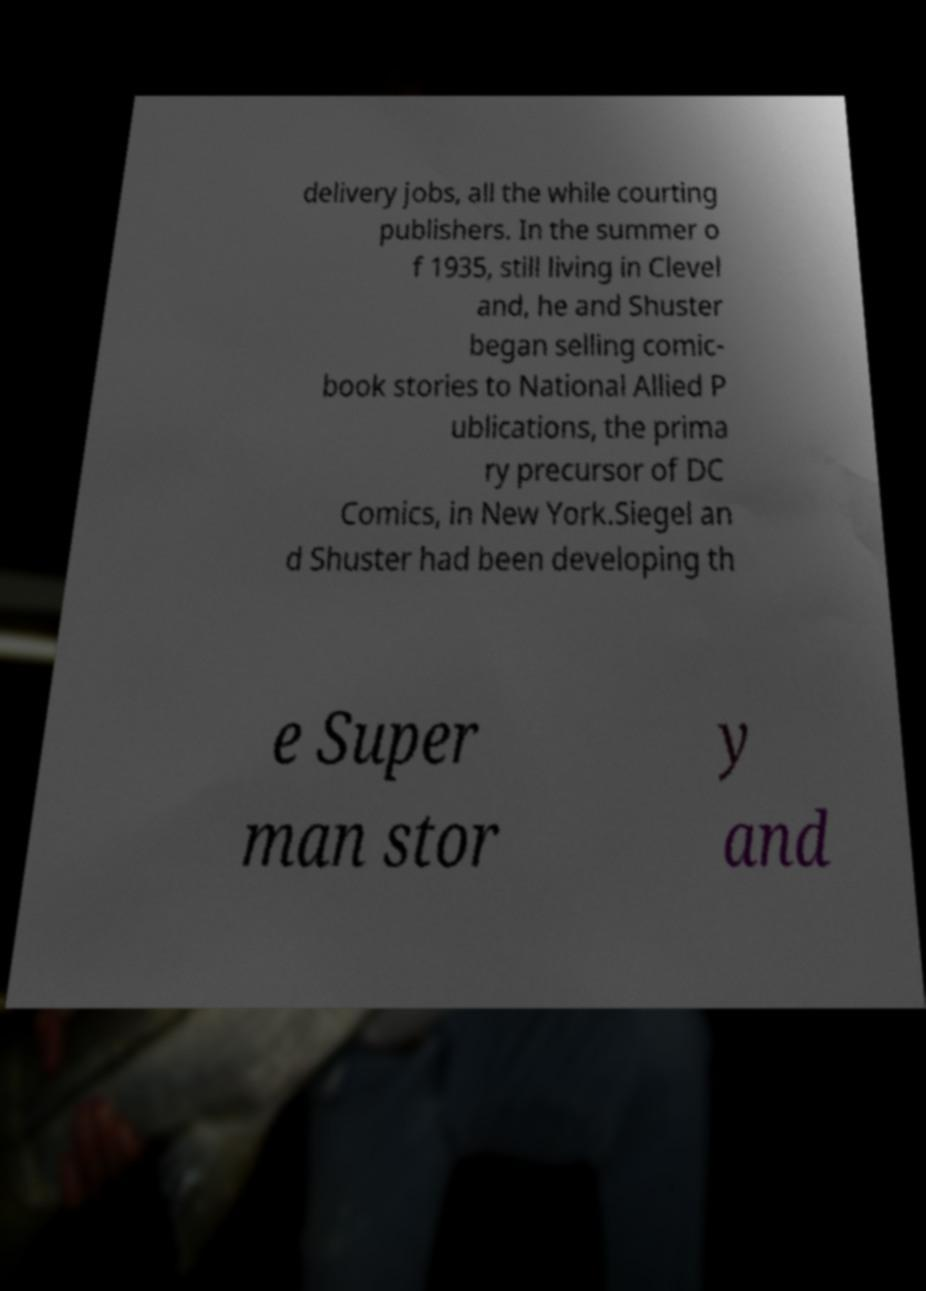Please read and relay the text visible in this image. What does it say? delivery jobs, all the while courting publishers. In the summer o f 1935, still living in Clevel and, he and Shuster began selling comic- book stories to National Allied P ublications, the prima ry precursor of DC Comics, in New York.Siegel an d Shuster had been developing th e Super man stor y and 